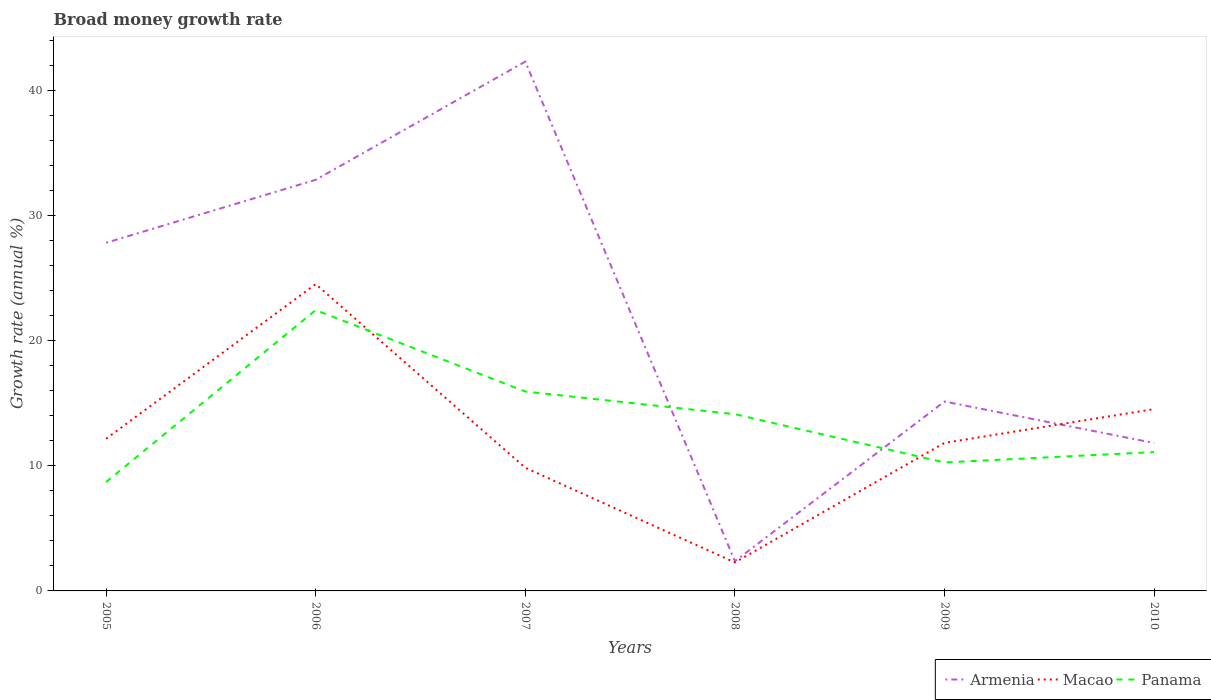How many different coloured lines are there?
Make the answer very short. 3. Does the line corresponding to Panama intersect with the line corresponding to Macao?
Your answer should be compact. Yes. Is the number of lines equal to the number of legend labels?
Provide a short and direct response. Yes. Across all years, what is the maximum growth rate in Macao?
Provide a succinct answer. 2.28. What is the total growth rate in Panama in the graph?
Provide a short and direct response. 3.86. What is the difference between the highest and the second highest growth rate in Panama?
Provide a succinct answer. 13.75. How many years are there in the graph?
Keep it short and to the point. 6. Are the values on the major ticks of Y-axis written in scientific E-notation?
Your answer should be very brief. No. What is the title of the graph?
Offer a terse response. Broad money growth rate. Does "Indonesia" appear as one of the legend labels in the graph?
Your response must be concise. No. What is the label or title of the X-axis?
Offer a very short reply. Years. What is the label or title of the Y-axis?
Give a very brief answer. Growth rate (annual %). What is the Growth rate (annual %) of Armenia in 2005?
Your answer should be compact. 27.84. What is the Growth rate (annual %) in Macao in 2005?
Make the answer very short. 12.17. What is the Growth rate (annual %) of Panama in 2005?
Your answer should be very brief. 8.71. What is the Growth rate (annual %) in Armenia in 2006?
Give a very brief answer. 32.88. What is the Growth rate (annual %) of Macao in 2006?
Provide a short and direct response. 24.54. What is the Growth rate (annual %) of Panama in 2006?
Provide a succinct answer. 22.46. What is the Growth rate (annual %) of Armenia in 2007?
Offer a very short reply. 42.33. What is the Growth rate (annual %) in Macao in 2007?
Your answer should be very brief. 9.85. What is the Growth rate (annual %) of Panama in 2007?
Keep it short and to the point. 15.95. What is the Growth rate (annual %) in Armenia in 2008?
Provide a succinct answer. 2.38. What is the Growth rate (annual %) in Macao in 2008?
Make the answer very short. 2.28. What is the Growth rate (annual %) of Panama in 2008?
Keep it short and to the point. 14.13. What is the Growth rate (annual %) of Armenia in 2009?
Offer a terse response. 15.15. What is the Growth rate (annual %) in Macao in 2009?
Ensure brevity in your answer.  11.84. What is the Growth rate (annual %) in Panama in 2009?
Offer a very short reply. 10.27. What is the Growth rate (annual %) of Armenia in 2010?
Your answer should be compact. 11.83. What is the Growth rate (annual %) in Macao in 2010?
Ensure brevity in your answer.  14.54. What is the Growth rate (annual %) in Panama in 2010?
Provide a succinct answer. 11.1. Across all years, what is the maximum Growth rate (annual %) in Armenia?
Make the answer very short. 42.33. Across all years, what is the maximum Growth rate (annual %) of Macao?
Provide a short and direct response. 24.54. Across all years, what is the maximum Growth rate (annual %) of Panama?
Ensure brevity in your answer.  22.46. Across all years, what is the minimum Growth rate (annual %) in Armenia?
Offer a very short reply. 2.38. Across all years, what is the minimum Growth rate (annual %) of Macao?
Make the answer very short. 2.28. Across all years, what is the minimum Growth rate (annual %) of Panama?
Your answer should be very brief. 8.71. What is the total Growth rate (annual %) in Armenia in the graph?
Offer a very short reply. 132.4. What is the total Growth rate (annual %) in Macao in the graph?
Provide a short and direct response. 75.21. What is the total Growth rate (annual %) in Panama in the graph?
Provide a short and direct response. 82.62. What is the difference between the Growth rate (annual %) in Armenia in 2005 and that in 2006?
Your answer should be compact. -5.04. What is the difference between the Growth rate (annual %) in Macao in 2005 and that in 2006?
Give a very brief answer. -12.37. What is the difference between the Growth rate (annual %) of Panama in 2005 and that in 2006?
Offer a very short reply. -13.75. What is the difference between the Growth rate (annual %) of Armenia in 2005 and that in 2007?
Your answer should be very brief. -14.49. What is the difference between the Growth rate (annual %) of Macao in 2005 and that in 2007?
Give a very brief answer. 2.32. What is the difference between the Growth rate (annual %) in Panama in 2005 and that in 2007?
Make the answer very short. -7.24. What is the difference between the Growth rate (annual %) in Armenia in 2005 and that in 2008?
Your response must be concise. 25.46. What is the difference between the Growth rate (annual %) in Macao in 2005 and that in 2008?
Provide a short and direct response. 9.89. What is the difference between the Growth rate (annual %) in Panama in 2005 and that in 2008?
Offer a very short reply. -5.42. What is the difference between the Growth rate (annual %) of Armenia in 2005 and that in 2009?
Keep it short and to the point. 12.7. What is the difference between the Growth rate (annual %) in Macao in 2005 and that in 2009?
Your answer should be very brief. 0.33. What is the difference between the Growth rate (annual %) of Panama in 2005 and that in 2009?
Ensure brevity in your answer.  -1.56. What is the difference between the Growth rate (annual %) in Armenia in 2005 and that in 2010?
Make the answer very short. 16.01. What is the difference between the Growth rate (annual %) in Macao in 2005 and that in 2010?
Provide a short and direct response. -2.37. What is the difference between the Growth rate (annual %) in Panama in 2005 and that in 2010?
Your answer should be very brief. -2.39. What is the difference between the Growth rate (annual %) in Armenia in 2006 and that in 2007?
Your response must be concise. -9.45. What is the difference between the Growth rate (annual %) of Macao in 2006 and that in 2007?
Keep it short and to the point. 14.69. What is the difference between the Growth rate (annual %) in Panama in 2006 and that in 2007?
Offer a very short reply. 6.51. What is the difference between the Growth rate (annual %) of Armenia in 2006 and that in 2008?
Provide a succinct answer. 30.5. What is the difference between the Growth rate (annual %) of Macao in 2006 and that in 2008?
Keep it short and to the point. 22.26. What is the difference between the Growth rate (annual %) of Panama in 2006 and that in 2008?
Keep it short and to the point. 8.32. What is the difference between the Growth rate (annual %) in Armenia in 2006 and that in 2009?
Keep it short and to the point. 17.73. What is the difference between the Growth rate (annual %) in Macao in 2006 and that in 2009?
Offer a terse response. 12.7. What is the difference between the Growth rate (annual %) of Panama in 2006 and that in 2009?
Your answer should be very brief. 12.19. What is the difference between the Growth rate (annual %) of Armenia in 2006 and that in 2010?
Your answer should be very brief. 21.05. What is the difference between the Growth rate (annual %) of Macao in 2006 and that in 2010?
Give a very brief answer. 10. What is the difference between the Growth rate (annual %) of Panama in 2006 and that in 2010?
Provide a short and direct response. 11.35. What is the difference between the Growth rate (annual %) of Armenia in 2007 and that in 2008?
Your answer should be compact. 39.95. What is the difference between the Growth rate (annual %) of Macao in 2007 and that in 2008?
Your answer should be compact. 7.57. What is the difference between the Growth rate (annual %) of Panama in 2007 and that in 2008?
Offer a very short reply. 1.81. What is the difference between the Growth rate (annual %) in Armenia in 2007 and that in 2009?
Your response must be concise. 27.18. What is the difference between the Growth rate (annual %) of Macao in 2007 and that in 2009?
Offer a very short reply. -1.99. What is the difference between the Growth rate (annual %) of Panama in 2007 and that in 2009?
Make the answer very short. 5.67. What is the difference between the Growth rate (annual %) of Armenia in 2007 and that in 2010?
Ensure brevity in your answer.  30.5. What is the difference between the Growth rate (annual %) in Macao in 2007 and that in 2010?
Provide a succinct answer. -4.69. What is the difference between the Growth rate (annual %) of Panama in 2007 and that in 2010?
Provide a succinct answer. 4.84. What is the difference between the Growth rate (annual %) in Armenia in 2008 and that in 2009?
Offer a very short reply. -12.77. What is the difference between the Growth rate (annual %) of Macao in 2008 and that in 2009?
Ensure brevity in your answer.  -9.56. What is the difference between the Growth rate (annual %) in Panama in 2008 and that in 2009?
Provide a succinct answer. 3.86. What is the difference between the Growth rate (annual %) of Armenia in 2008 and that in 2010?
Provide a succinct answer. -9.45. What is the difference between the Growth rate (annual %) of Macao in 2008 and that in 2010?
Offer a terse response. -12.26. What is the difference between the Growth rate (annual %) of Panama in 2008 and that in 2010?
Ensure brevity in your answer.  3.03. What is the difference between the Growth rate (annual %) of Armenia in 2009 and that in 2010?
Your answer should be very brief. 3.32. What is the difference between the Growth rate (annual %) of Macao in 2009 and that in 2010?
Provide a succinct answer. -2.7. What is the difference between the Growth rate (annual %) in Panama in 2009 and that in 2010?
Offer a terse response. -0.83. What is the difference between the Growth rate (annual %) in Armenia in 2005 and the Growth rate (annual %) in Macao in 2006?
Your answer should be very brief. 3.3. What is the difference between the Growth rate (annual %) of Armenia in 2005 and the Growth rate (annual %) of Panama in 2006?
Your response must be concise. 5.38. What is the difference between the Growth rate (annual %) in Macao in 2005 and the Growth rate (annual %) in Panama in 2006?
Make the answer very short. -10.29. What is the difference between the Growth rate (annual %) of Armenia in 2005 and the Growth rate (annual %) of Macao in 2007?
Keep it short and to the point. 17.99. What is the difference between the Growth rate (annual %) in Armenia in 2005 and the Growth rate (annual %) in Panama in 2007?
Provide a succinct answer. 11.9. What is the difference between the Growth rate (annual %) in Macao in 2005 and the Growth rate (annual %) in Panama in 2007?
Ensure brevity in your answer.  -3.77. What is the difference between the Growth rate (annual %) in Armenia in 2005 and the Growth rate (annual %) in Macao in 2008?
Make the answer very short. 25.56. What is the difference between the Growth rate (annual %) of Armenia in 2005 and the Growth rate (annual %) of Panama in 2008?
Give a very brief answer. 13.71. What is the difference between the Growth rate (annual %) of Macao in 2005 and the Growth rate (annual %) of Panama in 2008?
Your answer should be compact. -1.96. What is the difference between the Growth rate (annual %) of Armenia in 2005 and the Growth rate (annual %) of Macao in 2009?
Ensure brevity in your answer.  16. What is the difference between the Growth rate (annual %) in Armenia in 2005 and the Growth rate (annual %) in Panama in 2009?
Offer a terse response. 17.57. What is the difference between the Growth rate (annual %) of Macao in 2005 and the Growth rate (annual %) of Panama in 2009?
Your response must be concise. 1.9. What is the difference between the Growth rate (annual %) of Armenia in 2005 and the Growth rate (annual %) of Macao in 2010?
Keep it short and to the point. 13.3. What is the difference between the Growth rate (annual %) of Armenia in 2005 and the Growth rate (annual %) of Panama in 2010?
Your answer should be compact. 16.74. What is the difference between the Growth rate (annual %) in Macao in 2005 and the Growth rate (annual %) in Panama in 2010?
Offer a terse response. 1.07. What is the difference between the Growth rate (annual %) of Armenia in 2006 and the Growth rate (annual %) of Macao in 2007?
Your answer should be compact. 23.03. What is the difference between the Growth rate (annual %) in Armenia in 2006 and the Growth rate (annual %) in Panama in 2007?
Offer a very short reply. 16.93. What is the difference between the Growth rate (annual %) in Macao in 2006 and the Growth rate (annual %) in Panama in 2007?
Your answer should be very brief. 8.59. What is the difference between the Growth rate (annual %) of Armenia in 2006 and the Growth rate (annual %) of Macao in 2008?
Keep it short and to the point. 30.6. What is the difference between the Growth rate (annual %) of Armenia in 2006 and the Growth rate (annual %) of Panama in 2008?
Your answer should be very brief. 18.74. What is the difference between the Growth rate (annual %) in Macao in 2006 and the Growth rate (annual %) in Panama in 2008?
Provide a short and direct response. 10.4. What is the difference between the Growth rate (annual %) in Armenia in 2006 and the Growth rate (annual %) in Macao in 2009?
Offer a terse response. 21.04. What is the difference between the Growth rate (annual %) in Armenia in 2006 and the Growth rate (annual %) in Panama in 2009?
Your answer should be very brief. 22.6. What is the difference between the Growth rate (annual %) in Macao in 2006 and the Growth rate (annual %) in Panama in 2009?
Offer a terse response. 14.26. What is the difference between the Growth rate (annual %) in Armenia in 2006 and the Growth rate (annual %) in Macao in 2010?
Make the answer very short. 18.34. What is the difference between the Growth rate (annual %) of Armenia in 2006 and the Growth rate (annual %) of Panama in 2010?
Provide a short and direct response. 21.77. What is the difference between the Growth rate (annual %) in Macao in 2006 and the Growth rate (annual %) in Panama in 2010?
Provide a succinct answer. 13.43. What is the difference between the Growth rate (annual %) of Armenia in 2007 and the Growth rate (annual %) of Macao in 2008?
Provide a succinct answer. 40.05. What is the difference between the Growth rate (annual %) of Armenia in 2007 and the Growth rate (annual %) of Panama in 2008?
Provide a short and direct response. 28.2. What is the difference between the Growth rate (annual %) in Macao in 2007 and the Growth rate (annual %) in Panama in 2008?
Provide a succinct answer. -4.29. What is the difference between the Growth rate (annual %) in Armenia in 2007 and the Growth rate (annual %) in Macao in 2009?
Make the answer very short. 30.49. What is the difference between the Growth rate (annual %) in Armenia in 2007 and the Growth rate (annual %) in Panama in 2009?
Keep it short and to the point. 32.06. What is the difference between the Growth rate (annual %) in Macao in 2007 and the Growth rate (annual %) in Panama in 2009?
Ensure brevity in your answer.  -0.42. What is the difference between the Growth rate (annual %) of Armenia in 2007 and the Growth rate (annual %) of Macao in 2010?
Your answer should be very brief. 27.79. What is the difference between the Growth rate (annual %) in Armenia in 2007 and the Growth rate (annual %) in Panama in 2010?
Give a very brief answer. 31.22. What is the difference between the Growth rate (annual %) of Macao in 2007 and the Growth rate (annual %) of Panama in 2010?
Offer a very short reply. -1.26. What is the difference between the Growth rate (annual %) in Armenia in 2008 and the Growth rate (annual %) in Macao in 2009?
Make the answer very short. -9.46. What is the difference between the Growth rate (annual %) in Armenia in 2008 and the Growth rate (annual %) in Panama in 2009?
Your answer should be compact. -7.89. What is the difference between the Growth rate (annual %) of Macao in 2008 and the Growth rate (annual %) of Panama in 2009?
Offer a terse response. -8. What is the difference between the Growth rate (annual %) of Armenia in 2008 and the Growth rate (annual %) of Macao in 2010?
Keep it short and to the point. -12.16. What is the difference between the Growth rate (annual %) of Armenia in 2008 and the Growth rate (annual %) of Panama in 2010?
Your answer should be very brief. -8.73. What is the difference between the Growth rate (annual %) in Macao in 2008 and the Growth rate (annual %) in Panama in 2010?
Make the answer very short. -8.83. What is the difference between the Growth rate (annual %) in Armenia in 2009 and the Growth rate (annual %) in Macao in 2010?
Your response must be concise. 0.61. What is the difference between the Growth rate (annual %) in Armenia in 2009 and the Growth rate (annual %) in Panama in 2010?
Give a very brief answer. 4.04. What is the difference between the Growth rate (annual %) in Macao in 2009 and the Growth rate (annual %) in Panama in 2010?
Ensure brevity in your answer.  0.74. What is the average Growth rate (annual %) in Armenia per year?
Give a very brief answer. 22.07. What is the average Growth rate (annual %) of Macao per year?
Make the answer very short. 12.54. What is the average Growth rate (annual %) in Panama per year?
Make the answer very short. 13.77. In the year 2005, what is the difference between the Growth rate (annual %) in Armenia and Growth rate (annual %) in Macao?
Ensure brevity in your answer.  15.67. In the year 2005, what is the difference between the Growth rate (annual %) in Armenia and Growth rate (annual %) in Panama?
Your answer should be very brief. 19.13. In the year 2005, what is the difference between the Growth rate (annual %) of Macao and Growth rate (annual %) of Panama?
Provide a short and direct response. 3.46. In the year 2006, what is the difference between the Growth rate (annual %) of Armenia and Growth rate (annual %) of Macao?
Your answer should be very brief. 8.34. In the year 2006, what is the difference between the Growth rate (annual %) in Armenia and Growth rate (annual %) in Panama?
Make the answer very short. 10.42. In the year 2006, what is the difference between the Growth rate (annual %) in Macao and Growth rate (annual %) in Panama?
Provide a succinct answer. 2.08. In the year 2007, what is the difference between the Growth rate (annual %) in Armenia and Growth rate (annual %) in Macao?
Your answer should be very brief. 32.48. In the year 2007, what is the difference between the Growth rate (annual %) of Armenia and Growth rate (annual %) of Panama?
Keep it short and to the point. 26.38. In the year 2007, what is the difference between the Growth rate (annual %) of Macao and Growth rate (annual %) of Panama?
Give a very brief answer. -6.1. In the year 2008, what is the difference between the Growth rate (annual %) of Armenia and Growth rate (annual %) of Macao?
Your answer should be compact. 0.1. In the year 2008, what is the difference between the Growth rate (annual %) of Armenia and Growth rate (annual %) of Panama?
Your answer should be very brief. -11.76. In the year 2008, what is the difference between the Growth rate (annual %) in Macao and Growth rate (annual %) in Panama?
Provide a succinct answer. -11.86. In the year 2009, what is the difference between the Growth rate (annual %) of Armenia and Growth rate (annual %) of Macao?
Give a very brief answer. 3.31. In the year 2009, what is the difference between the Growth rate (annual %) of Armenia and Growth rate (annual %) of Panama?
Your answer should be very brief. 4.87. In the year 2009, what is the difference between the Growth rate (annual %) of Macao and Growth rate (annual %) of Panama?
Ensure brevity in your answer.  1.57. In the year 2010, what is the difference between the Growth rate (annual %) of Armenia and Growth rate (annual %) of Macao?
Provide a succinct answer. -2.71. In the year 2010, what is the difference between the Growth rate (annual %) of Armenia and Growth rate (annual %) of Panama?
Your response must be concise. 0.72. In the year 2010, what is the difference between the Growth rate (annual %) of Macao and Growth rate (annual %) of Panama?
Your response must be concise. 3.44. What is the ratio of the Growth rate (annual %) in Armenia in 2005 to that in 2006?
Offer a very short reply. 0.85. What is the ratio of the Growth rate (annual %) of Macao in 2005 to that in 2006?
Give a very brief answer. 0.5. What is the ratio of the Growth rate (annual %) in Panama in 2005 to that in 2006?
Ensure brevity in your answer.  0.39. What is the ratio of the Growth rate (annual %) of Armenia in 2005 to that in 2007?
Keep it short and to the point. 0.66. What is the ratio of the Growth rate (annual %) in Macao in 2005 to that in 2007?
Provide a succinct answer. 1.24. What is the ratio of the Growth rate (annual %) of Panama in 2005 to that in 2007?
Provide a succinct answer. 0.55. What is the ratio of the Growth rate (annual %) of Armenia in 2005 to that in 2008?
Keep it short and to the point. 11.7. What is the ratio of the Growth rate (annual %) of Macao in 2005 to that in 2008?
Provide a short and direct response. 5.35. What is the ratio of the Growth rate (annual %) of Panama in 2005 to that in 2008?
Give a very brief answer. 0.62. What is the ratio of the Growth rate (annual %) in Armenia in 2005 to that in 2009?
Keep it short and to the point. 1.84. What is the ratio of the Growth rate (annual %) of Macao in 2005 to that in 2009?
Give a very brief answer. 1.03. What is the ratio of the Growth rate (annual %) in Panama in 2005 to that in 2009?
Your answer should be compact. 0.85. What is the ratio of the Growth rate (annual %) of Armenia in 2005 to that in 2010?
Your answer should be very brief. 2.35. What is the ratio of the Growth rate (annual %) in Macao in 2005 to that in 2010?
Your response must be concise. 0.84. What is the ratio of the Growth rate (annual %) of Panama in 2005 to that in 2010?
Your response must be concise. 0.78. What is the ratio of the Growth rate (annual %) in Armenia in 2006 to that in 2007?
Provide a succinct answer. 0.78. What is the ratio of the Growth rate (annual %) of Macao in 2006 to that in 2007?
Your answer should be compact. 2.49. What is the ratio of the Growth rate (annual %) of Panama in 2006 to that in 2007?
Your response must be concise. 1.41. What is the ratio of the Growth rate (annual %) of Armenia in 2006 to that in 2008?
Give a very brief answer. 13.82. What is the ratio of the Growth rate (annual %) in Macao in 2006 to that in 2008?
Ensure brevity in your answer.  10.78. What is the ratio of the Growth rate (annual %) in Panama in 2006 to that in 2008?
Your response must be concise. 1.59. What is the ratio of the Growth rate (annual %) of Armenia in 2006 to that in 2009?
Offer a terse response. 2.17. What is the ratio of the Growth rate (annual %) in Macao in 2006 to that in 2009?
Offer a terse response. 2.07. What is the ratio of the Growth rate (annual %) in Panama in 2006 to that in 2009?
Make the answer very short. 2.19. What is the ratio of the Growth rate (annual %) of Armenia in 2006 to that in 2010?
Offer a terse response. 2.78. What is the ratio of the Growth rate (annual %) of Macao in 2006 to that in 2010?
Make the answer very short. 1.69. What is the ratio of the Growth rate (annual %) in Panama in 2006 to that in 2010?
Provide a succinct answer. 2.02. What is the ratio of the Growth rate (annual %) of Armenia in 2007 to that in 2008?
Provide a short and direct response. 17.8. What is the ratio of the Growth rate (annual %) of Macao in 2007 to that in 2008?
Offer a very short reply. 4.33. What is the ratio of the Growth rate (annual %) of Panama in 2007 to that in 2008?
Offer a terse response. 1.13. What is the ratio of the Growth rate (annual %) of Armenia in 2007 to that in 2009?
Your response must be concise. 2.79. What is the ratio of the Growth rate (annual %) in Macao in 2007 to that in 2009?
Offer a very short reply. 0.83. What is the ratio of the Growth rate (annual %) in Panama in 2007 to that in 2009?
Your answer should be compact. 1.55. What is the ratio of the Growth rate (annual %) in Armenia in 2007 to that in 2010?
Your answer should be compact. 3.58. What is the ratio of the Growth rate (annual %) in Macao in 2007 to that in 2010?
Provide a succinct answer. 0.68. What is the ratio of the Growth rate (annual %) of Panama in 2007 to that in 2010?
Your answer should be very brief. 1.44. What is the ratio of the Growth rate (annual %) in Armenia in 2008 to that in 2009?
Give a very brief answer. 0.16. What is the ratio of the Growth rate (annual %) of Macao in 2008 to that in 2009?
Your answer should be very brief. 0.19. What is the ratio of the Growth rate (annual %) in Panama in 2008 to that in 2009?
Give a very brief answer. 1.38. What is the ratio of the Growth rate (annual %) of Armenia in 2008 to that in 2010?
Your answer should be very brief. 0.2. What is the ratio of the Growth rate (annual %) of Macao in 2008 to that in 2010?
Your response must be concise. 0.16. What is the ratio of the Growth rate (annual %) in Panama in 2008 to that in 2010?
Your answer should be compact. 1.27. What is the ratio of the Growth rate (annual %) in Armenia in 2009 to that in 2010?
Keep it short and to the point. 1.28. What is the ratio of the Growth rate (annual %) in Macao in 2009 to that in 2010?
Give a very brief answer. 0.81. What is the ratio of the Growth rate (annual %) in Panama in 2009 to that in 2010?
Provide a short and direct response. 0.93. What is the difference between the highest and the second highest Growth rate (annual %) of Armenia?
Provide a succinct answer. 9.45. What is the difference between the highest and the second highest Growth rate (annual %) in Macao?
Provide a short and direct response. 10. What is the difference between the highest and the second highest Growth rate (annual %) of Panama?
Offer a terse response. 6.51. What is the difference between the highest and the lowest Growth rate (annual %) of Armenia?
Provide a succinct answer. 39.95. What is the difference between the highest and the lowest Growth rate (annual %) of Macao?
Your answer should be compact. 22.26. What is the difference between the highest and the lowest Growth rate (annual %) in Panama?
Provide a short and direct response. 13.75. 